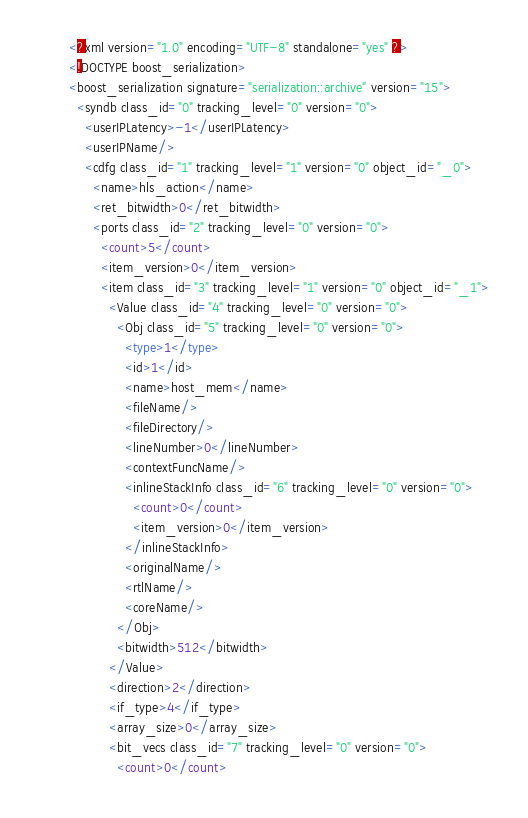Convert code to text. <code><loc_0><loc_0><loc_500><loc_500><_Ada_><?xml version="1.0" encoding="UTF-8" standalone="yes" ?>
<!DOCTYPE boost_serialization>
<boost_serialization signature="serialization::archive" version="15">
  <syndb class_id="0" tracking_level="0" version="0">
    <userIPLatency>-1</userIPLatency>
    <userIPName/>
    <cdfg class_id="1" tracking_level="1" version="0" object_id="_0">
      <name>hls_action</name>
      <ret_bitwidth>0</ret_bitwidth>
      <ports class_id="2" tracking_level="0" version="0">
        <count>5</count>
        <item_version>0</item_version>
        <item class_id="3" tracking_level="1" version="0" object_id="_1">
          <Value class_id="4" tracking_level="0" version="0">
            <Obj class_id="5" tracking_level="0" version="0">
              <type>1</type>
              <id>1</id>
              <name>host_mem</name>
              <fileName/>
              <fileDirectory/>
              <lineNumber>0</lineNumber>
              <contextFuncName/>
              <inlineStackInfo class_id="6" tracking_level="0" version="0">
                <count>0</count>
                <item_version>0</item_version>
              </inlineStackInfo>
              <originalName/>
              <rtlName/>
              <coreName/>
            </Obj>
            <bitwidth>512</bitwidth>
          </Value>
          <direction>2</direction>
          <if_type>4</if_type>
          <array_size>0</array_size>
          <bit_vecs class_id="7" tracking_level="0" version="0">
            <count>0</count></code> 